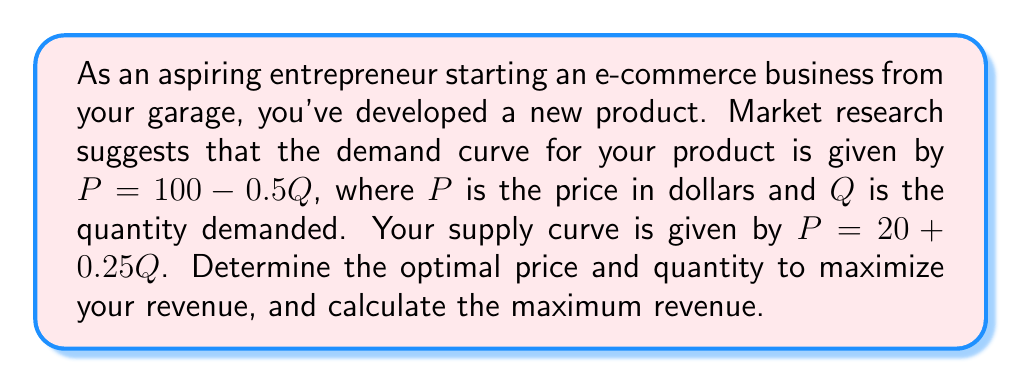What is the answer to this math problem? To solve this problem, we'll follow these steps:

1) First, we need to find the equilibrium point where supply equals demand. This is the point where the two equations intersect:

   $100 - 0.5Q = 20 + 0.25Q$

2) Solve for Q:
   $80 = 0.75Q$
   $Q = 106.67$

3) Now we can find the equilibrium price by plugging this Q back into either the supply or demand equation. Let's use the demand equation:

   $P = 100 - 0.5(106.67) = 46.67$

4) However, this equilibrium point doesn't necessarily maximize revenue. To find the revenue-maximizing point, we need to use the demand curve and find where marginal revenue equals zero.

5) The demand curve is $P = 100 - 0.5Q$. Revenue (R) is price times quantity:

   $R = PQ = (100 - 0.5Q)Q = 100Q - 0.5Q^2$

6) Marginal revenue is the derivative of revenue with respect to Q:

   $\frac{dR}{dQ} = 100 - Q$

7) Set this equal to zero and solve:

   $100 - Q = 0$
   $Q = 100$

8) Now we can find the optimal price by plugging this Q back into the demand equation:

   $P = 100 - 0.5(100) = 50$

9) Finally, calculate the maximum revenue:

   $R = PQ = 50 * 100 = 5000$

Therefore, to maximize revenue, you should price your product at $50 and expect to sell 100 units.
Answer: Optimal price: $50
Optimal quantity: 100 units
Maximum revenue: $5000 